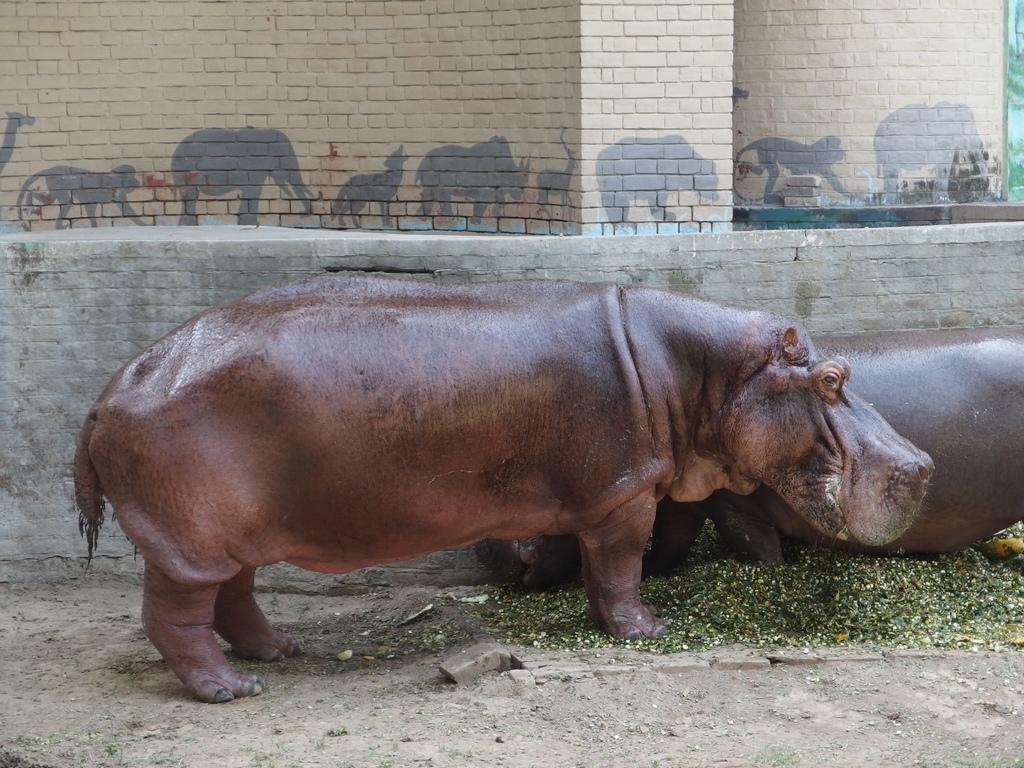What animals are present in the image? There are two hippopotamuses in the image. What color are the hippopotamuses? The hippopotamuses are brown in color. What is the price of the orange in the image? There is no orange present in the image. How many balls are visible in the image? There are no balls visible in the image. 